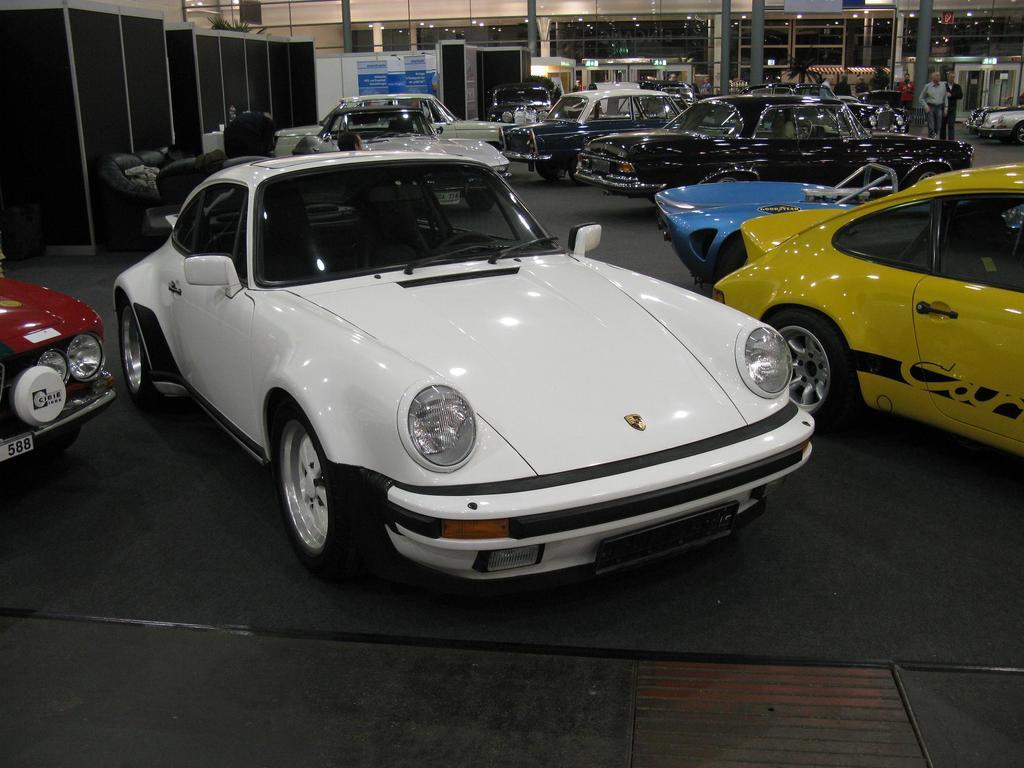Please provide a concise description of this image. In this image there are cars and on the left side there are objects which are black in colour. On the right side there are persons standing. In the background there are lights and there are pillars and there are boards with some text written on it. 